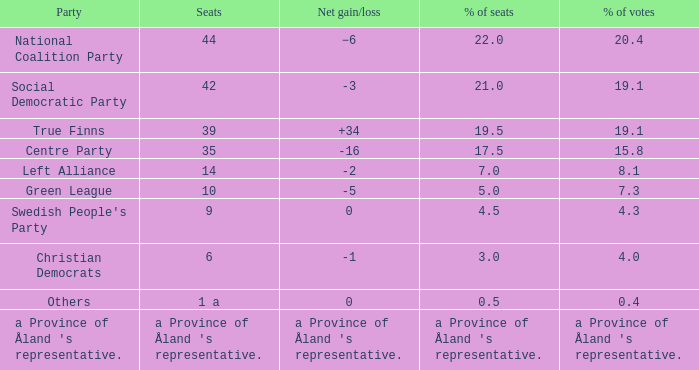When there was a net gain/loss of +34, what was the percentage of seats that party held? 19.5. 